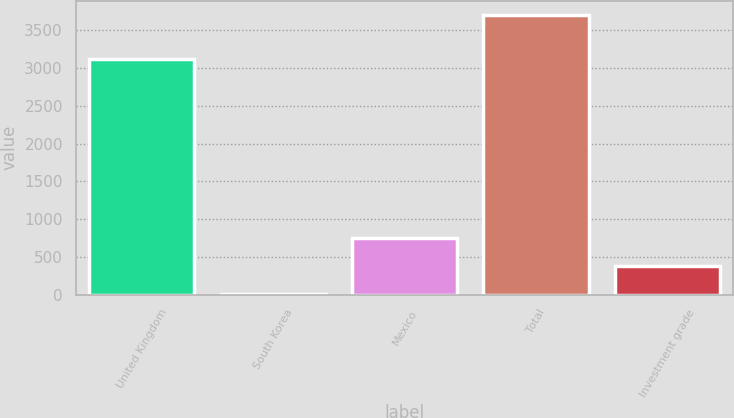Convert chart to OTSL. <chart><loc_0><loc_0><loc_500><loc_500><bar_chart><fcel>United Kingdom<fcel>South Korea<fcel>Mexico<fcel>Total<fcel>Investment grade<nl><fcel>3117<fcel>14<fcel>753.4<fcel>3711<fcel>383.7<nl></chart> 